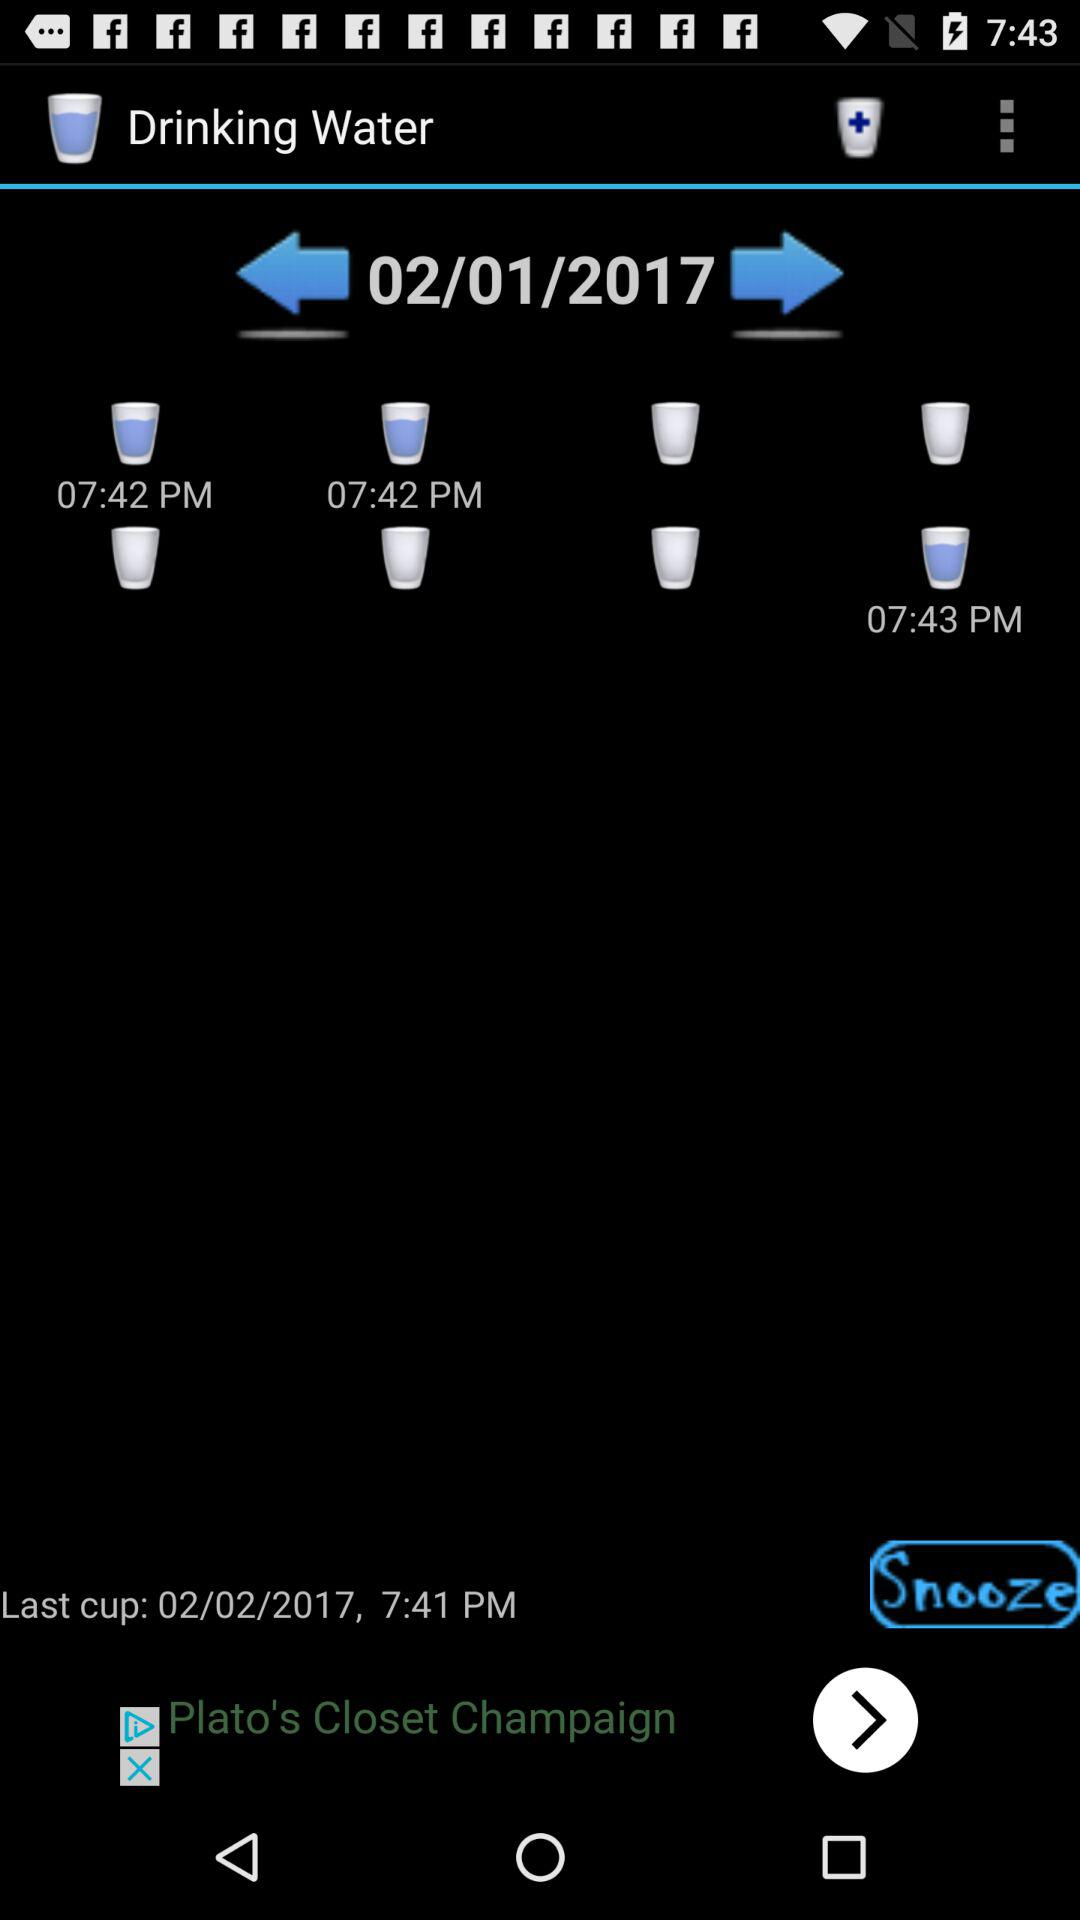What time was the last cup of water drunk? The last cup of water was drunk at 7:41 PM. 